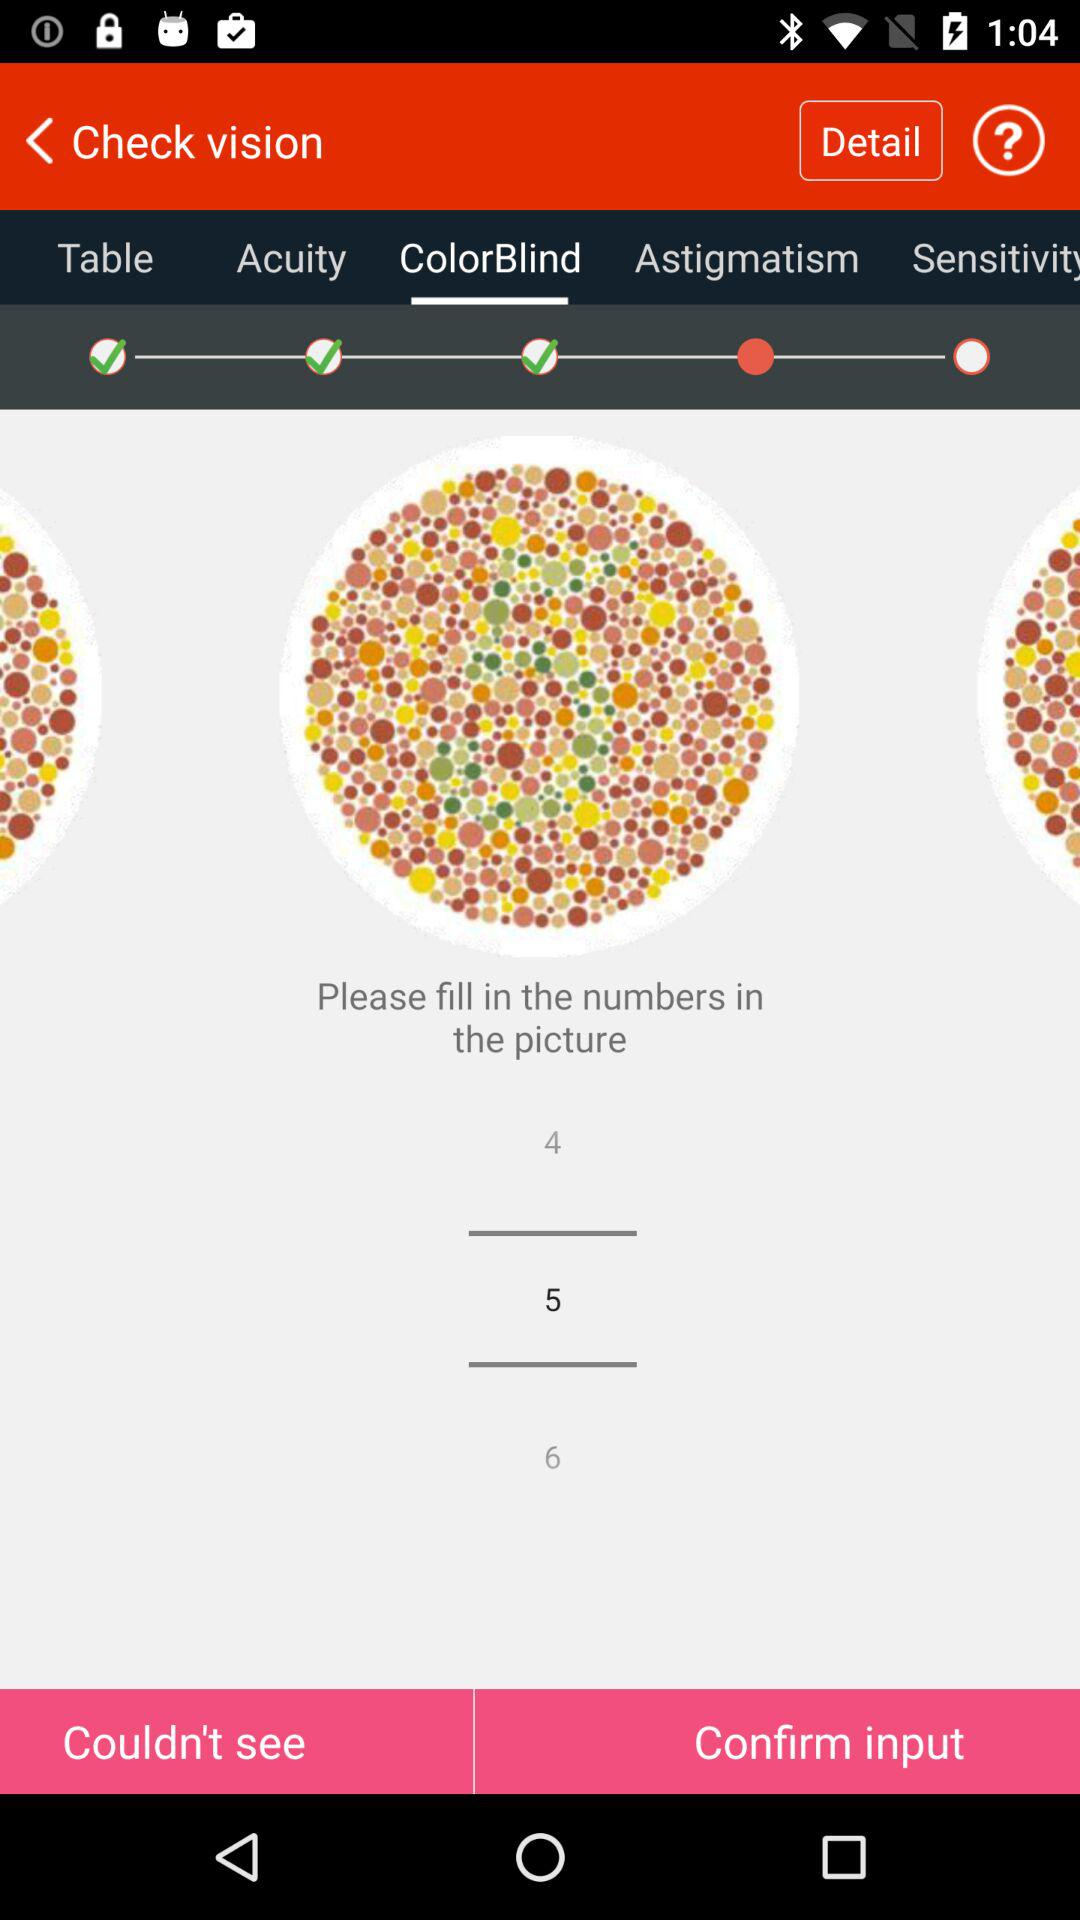What is the number that has been filled? The number that has been filled is 5. 